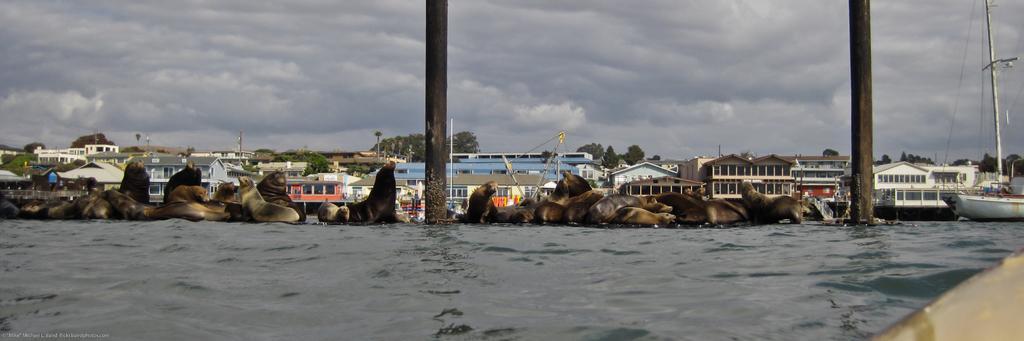Could you give a brief overview of what you see in this image? In this picture I can see many sea lions on the water, beside that I can see the poles. On the right I can see the boards on the water. In the background I can see the building, electric poles, wires, trees, tower and other objects. At the top I can see the sky and clouds. 